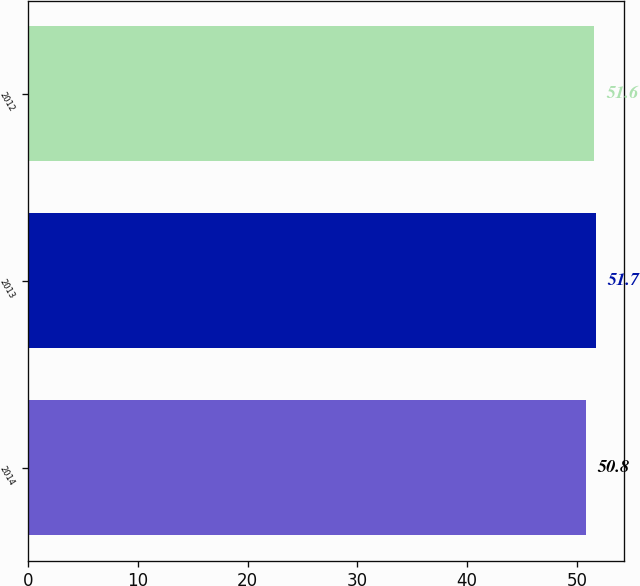Convert chart. <chart><loc_0><loc_0><loc_500><loc_500><bar_chart><fcel>2014<fcel>2013<fcel>2012<nl><fcel>50.8<fcel>51.7<fcel>51.6<nl></chart> 